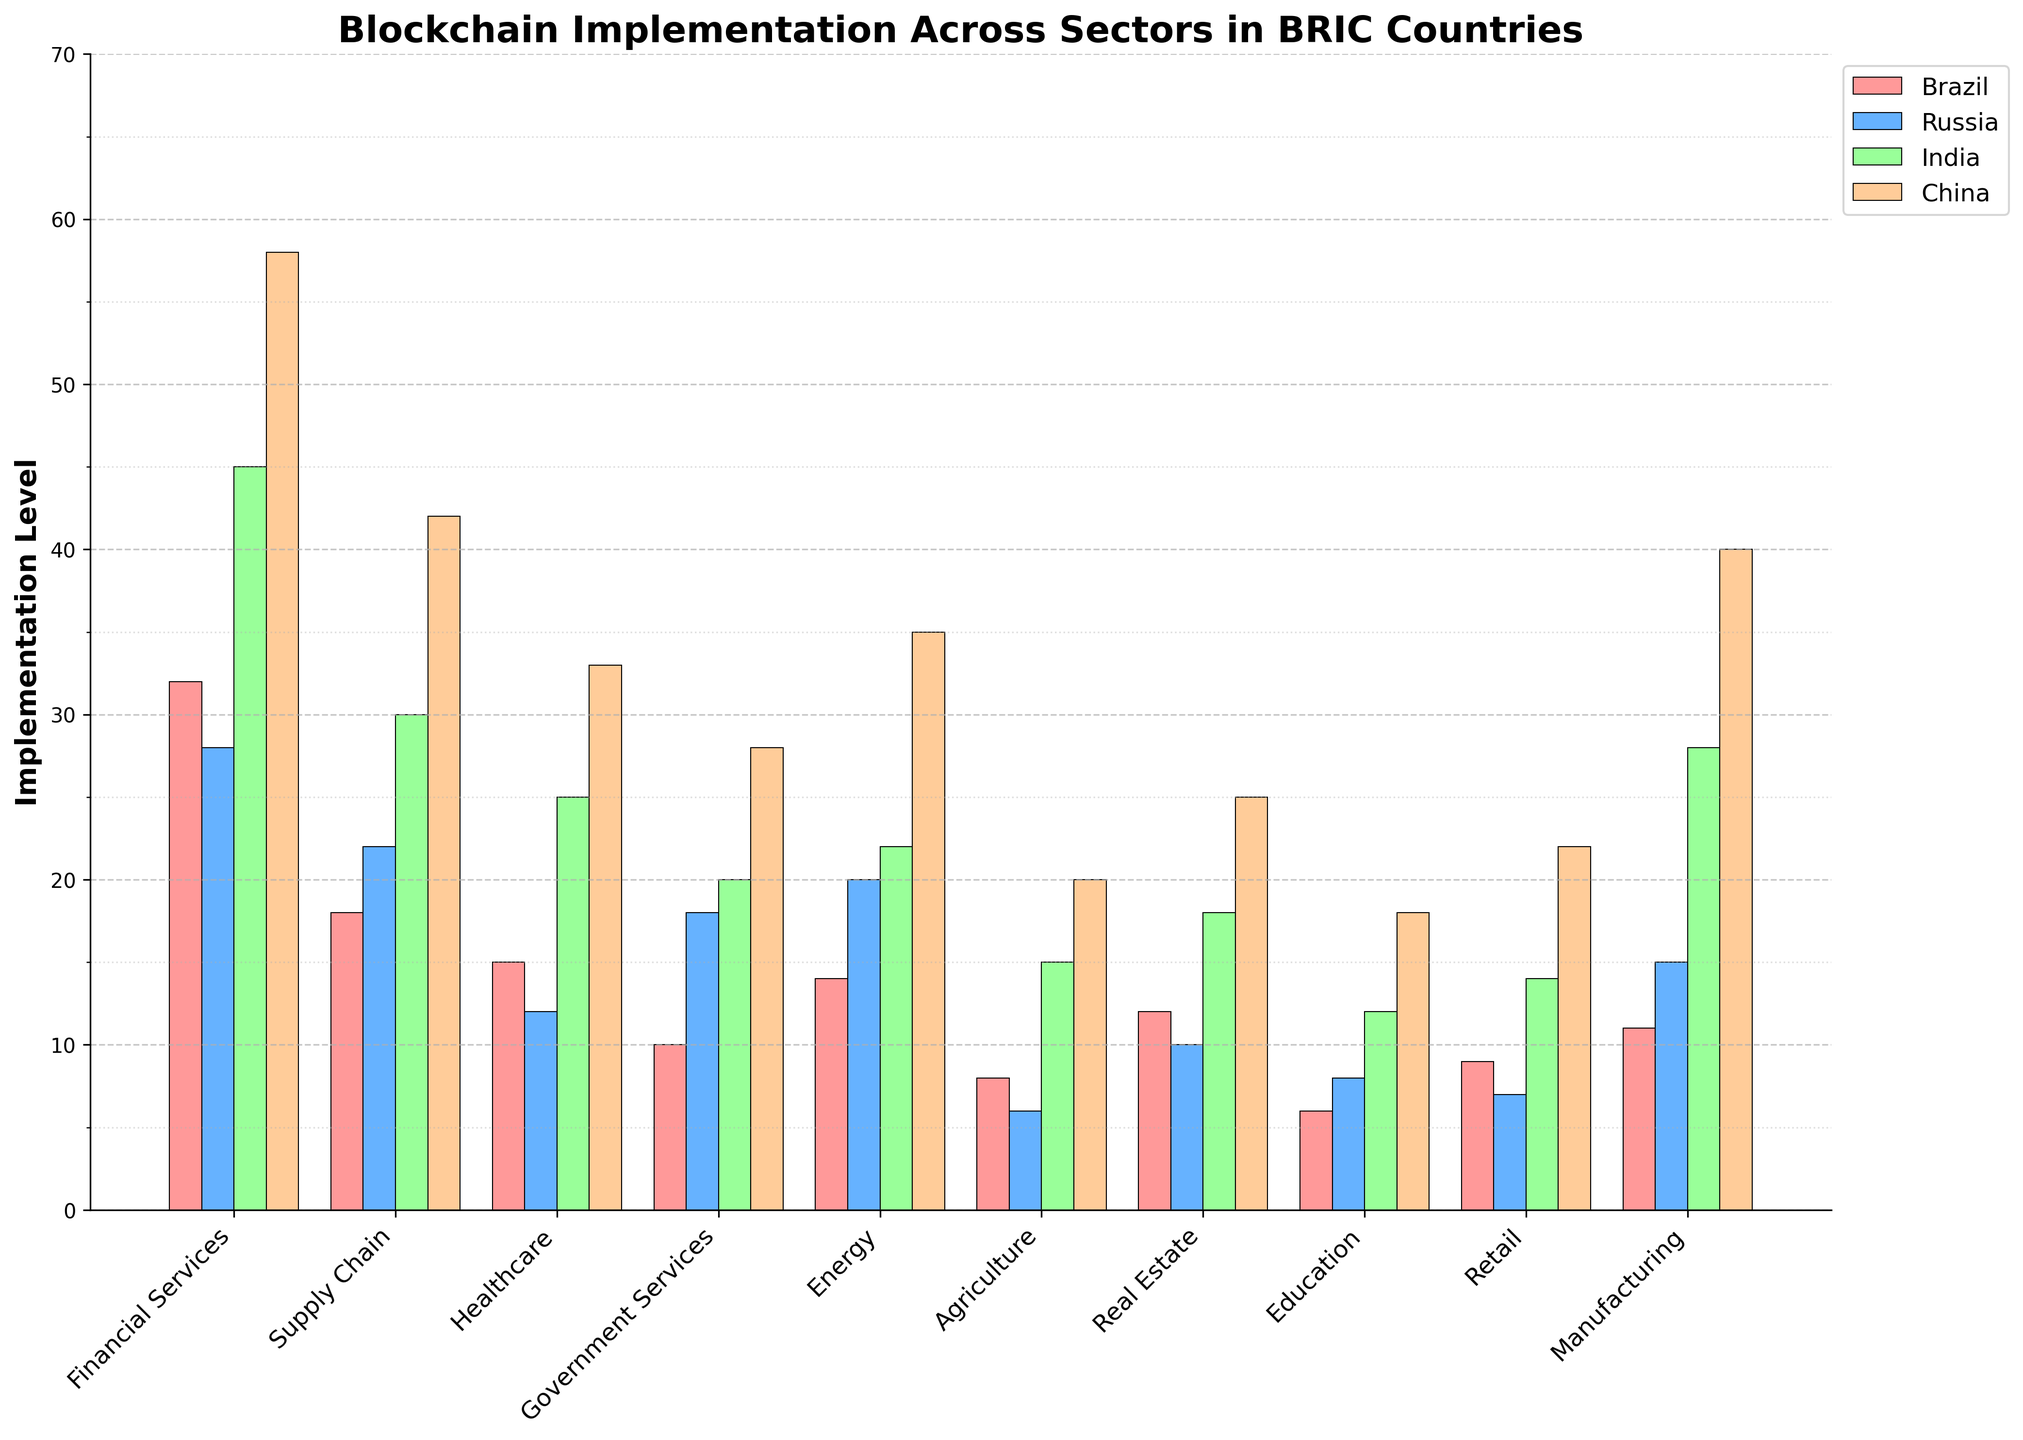What is the highest level of blockchain implementation across all sectors and countries? By looking at all the bars in the chart, we can see that the highest bar represents China in Financial Services, with a value of 58.
Answer: 58 Which sector has the lowest level of blockchain implementation in Brazil? By examining the bars corresponding to Brazil, we can see that Agriculture has the lowest value at 8.
Answer: Agriculture Between Financial Services and Supply Chain sectors in Russia, which one has a higher implementation level of blockchain, and by how much? Comparing the bars in Russia, the Financial Services sector has an implementation level of 28, while the Supply Chain sector has 22. The difference is 28 - 22 = 6.
Answer: Financial Services by 6 What is the total level of blockchain implementation in the Healthcare sector across all BRIC countries? Summing the values of the Healthcare sector for each country: 15 (Brazil) + 12 (Russia) + 25 (India) + 33 (China) = 85.
Answer: 85 Which country has the greatest implementation level in the Energy sector, and what is the value? Observing the Energy sector bars, China has the highest implementation level of 35.
Answer: China, 35 What's the average implementation level in the Real Estate sector across all BRIC countries? Summing the Real Estate values: 12 (Brazil) + 10 (Russia) + 18 (India) + 25 (China) = 65, then dividing by the number of countries (4): 65 / 4 = 16.25.
Answer: 16.25 In which sector does India have the highest blockchain implementation, and what is the value? Looking at all bars for India, the highest implementation is in the Financial Services sector with a value of 45.
Answer: Financial Services, 45 How much higher is China's level of blockchain implementation in the Retail sector compared to Russia? China's implementation in Retail is 22, and Russia's is 7. The difference is 22 - 7 = 15.
Answer: 15 What is the difference in blockchain implementation levels between the Manufacturing sector and the Education sector in China? China's Manufacturing value is 40, and Education is 18. The difference is 40 - 18 = 22.
Answer: 22 